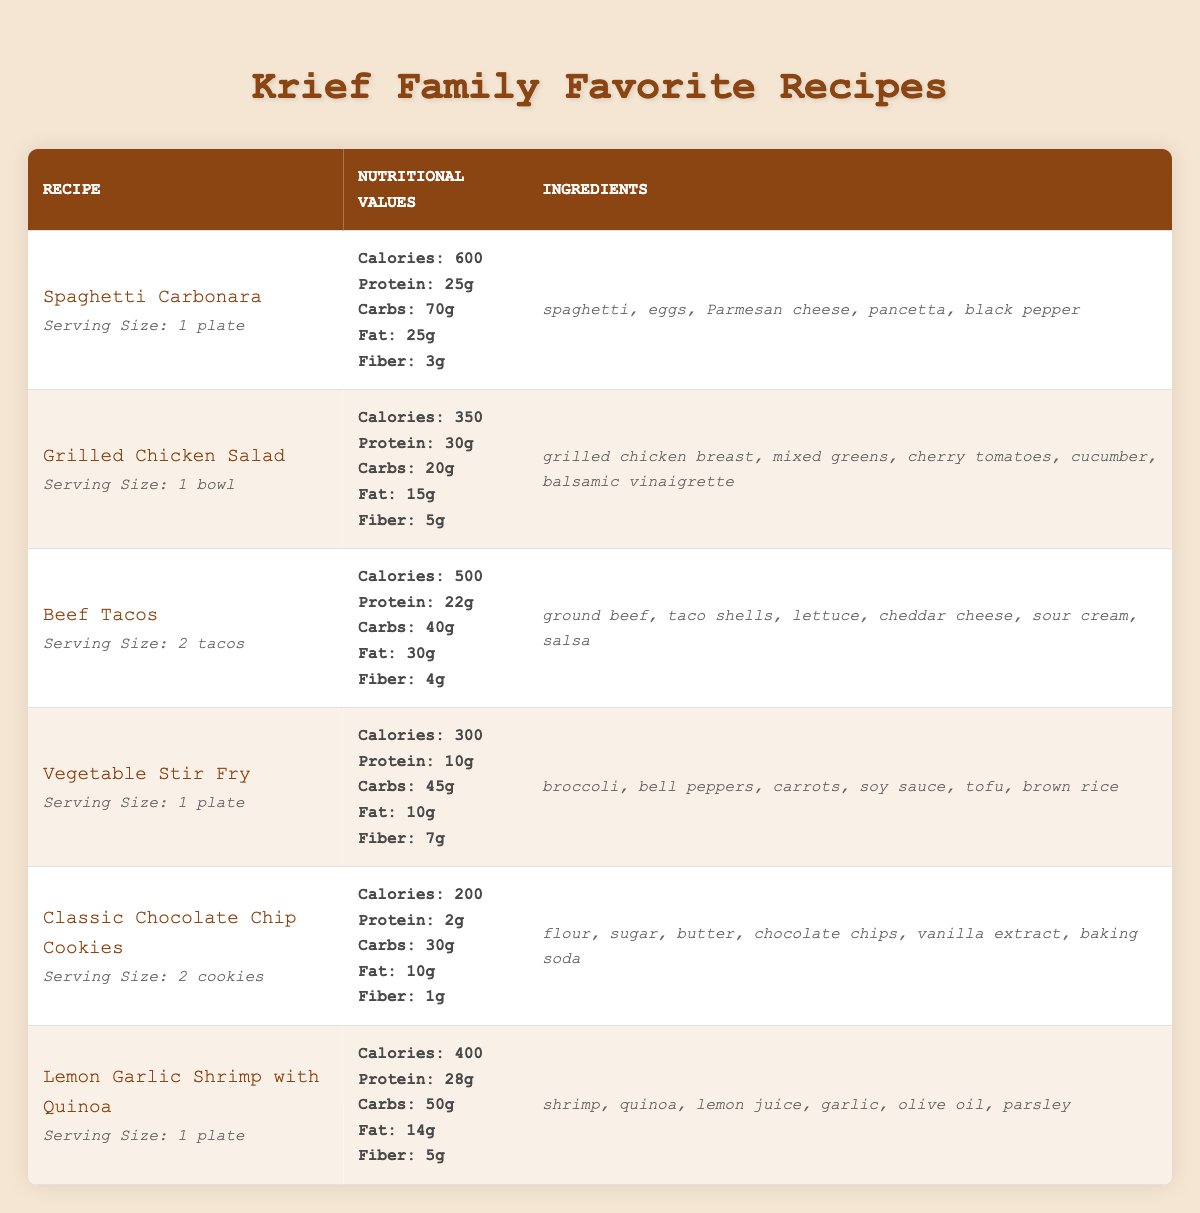What is the serving size for Beef Tacos? The table indicates that the serving size for Beef Tacos is specified as "2 tacos."
Answer: 2 tacos How many calories are in the Grilled Chicken Salad? According to the table, the nutritional value for Grilled Chicken Salad lists calories as 350.
Answer: 350 calories Which recipe has the highest protein content per serving? Scanning through the protein values, Spaghetti Carbonara has 25g, Grilled Chicken Salad has 30g, Beef Tacos have 22g, Vegetable Stir Fry has 10g, Classic Chocolate Chip Cookies have 2g, and Lemon Garlic Shrimp with Quinoa has 28g. The highest is 30g for Grilled Chicken Salad.
Answer: Grilled Chicken Salad What are the ingredients for Vegetable Stir Fry? The table lists the ingredients for Vegetable Stir Fry as broccoli, bell peppers, carrots, soy sauce, tofu, and brown rice.
Answer: broccoli, bell peppers, carrots, soy sauce, tofu, brown rice What is the total number of grams of carbohydrates in Spaghetti Carbonara and Beef Tacos combined? The carbohydrates for Spaghetti Carbonara is 70g and Beef Tacos is 40g. Adding these values gives 70 + 40 = 110g of carbohydrates combined.
Answer: 110g Is there a recipe that contains shrimp? The table shows that Lemon Garlic Shrimp with Quinoa lists shrimp as one of its ingredients, confirming there is a recipe that contains shrimp.
Answer: Yes Which recipe has the lowest fat content? The recipes have the following fat content: Spaghetti Carbonara (25g), Grilled Chicken Salad (15g), Beef Tacos (30g), Vegetable Stir Fry (10g), Classic Chocolate Chip Cookies (10g), and Lemon Garlic Shrimp with Quinoa (14g). The lowest values, shared by Vegetable Stir Fry and Classic Chocolate Chip Cookies, are both 10g.
Answer: Vegetable Stir Fry and Classic Chocolate Chip Cookies What is the average calorie content among all recipes? The total calories for each recipe are: Spaghetti Carbonara (600), Grilled Chicken Salad (350), Beef Tacos (500), Vegetable Stir Fry (300), Classic Chocolate Chip Cookies (200), and Lemon Garlic Shrimp with Quinoa (400), totaling 600 + 350 + 500 + 300 + 200 + 400 = 2350 calories across 6 recipes. The average is 2350/6 = 391.67, rounding to 392 calories.
Answer: 392 calories How many grams of fiber does the recipe with the highest calorie content have? The highest calorie content comes from Spaghetti Carbonara, which has 600 calories and lists 3g of fiber.
Answer: 3g If I wanted to make a meal with both protein and fiber, which recipe would provide the most combined value? The protein and fiber values are: Spaghetti Carbonara (25g protein, 3g fiber), Grilled Chicken Salad (30g protein, 5g fiber), Beef Tacos (22g protein, 4g fiber), Vegetable Stir Fry (10g protein, 7g fiber), Classic Chocolate Chip Cookies (2g protein, 1g fiber), and Lemon Garlic Shrimp with Quinoa (28g protein, 5g fiber). The combined values are 28g from Lemon Garlic Shrimp with Quinoa and 7g fiber, totaling 35g. Grilled Chicken Salad provides 35g as well, so either can be selected.
Answer: Grilled Chicken Salad or Lemon Garlic Shrimp with Quinoa 